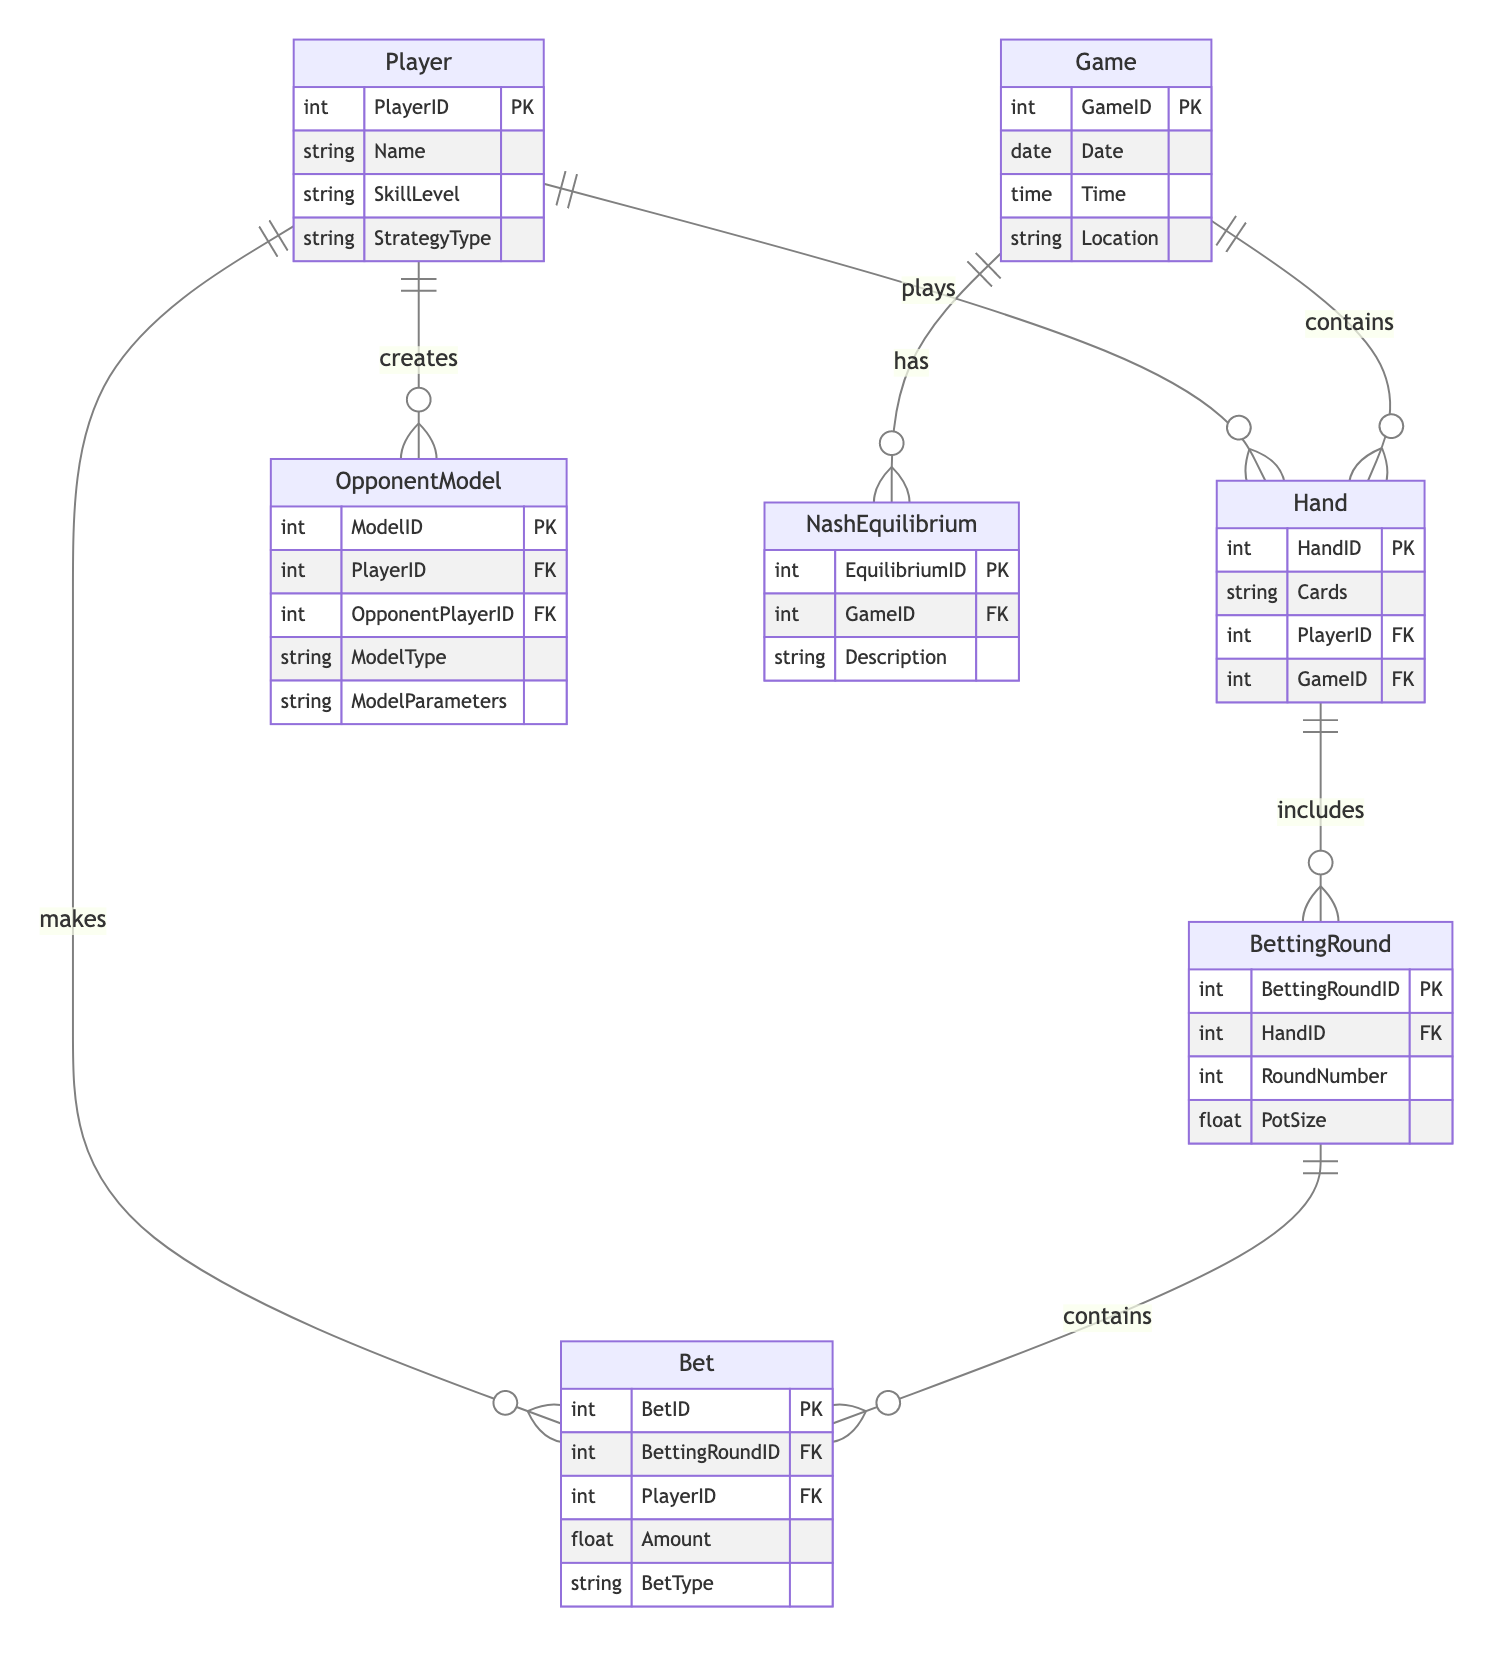What entity has the primary key PlayerID? The entity that has the primary key PlayerID is the Player entity, which identifies each player uniquely in the database.
Answer: Player How many attributes are in the Game entity? The Game entity contains four attributes: GameID, Date, Time, and Location. This can be determined by counting the listed attributes under the Game entity in the diagram.
Answer: 4 What is the relationship type between Hand and BettingRound? The relationship between Hand and BettingRound is "one to many," indicating that each Hand can include multiple BettingRounds. This is shown by the notation connecting the two entities in the diagram.
Answer: one to many Which entity contains the attribute Amount? The entity that contains the attribute Amount is the Bet entity, where the amount of each bet made during a betting round is recorded.
Answer: Bet How many models can a Player create for their Opponent? A Player can create multiple OpponentModels. The relationship from Player to OpponentModel is "one to many," suggesting that one player can have multiple models for different opponents.
Answer: many What is the relationship between Game and NashEquilibrium? The relationship between Game and NashEquilibrium is "one to many," meaning that each game can have multiple Nash Equilibriums associated with it. This detail is depicted in the diagram's relationship lines.
Answer: one to many Which entity is linked to the attribute PotSize? The attribute PotSize is linked to the BettingRound entity, where it represents the total size of the pot during that particular betting round.
Answer: BettingRound How many players are involved in creating an OpponentModel? Two Players are involved in creating an OpponentModel: the Player creating the model and the OpponentPlayer being modeled. This is shown through the relationships connected to the OpponentModel entity.
Answer: 2 What is the primary key of the BettingRound entity? The primary key of the BettingRound entity is BettingRoundID, which uniquely identifies each betting round in the system.
Answer: BettingRoundID 